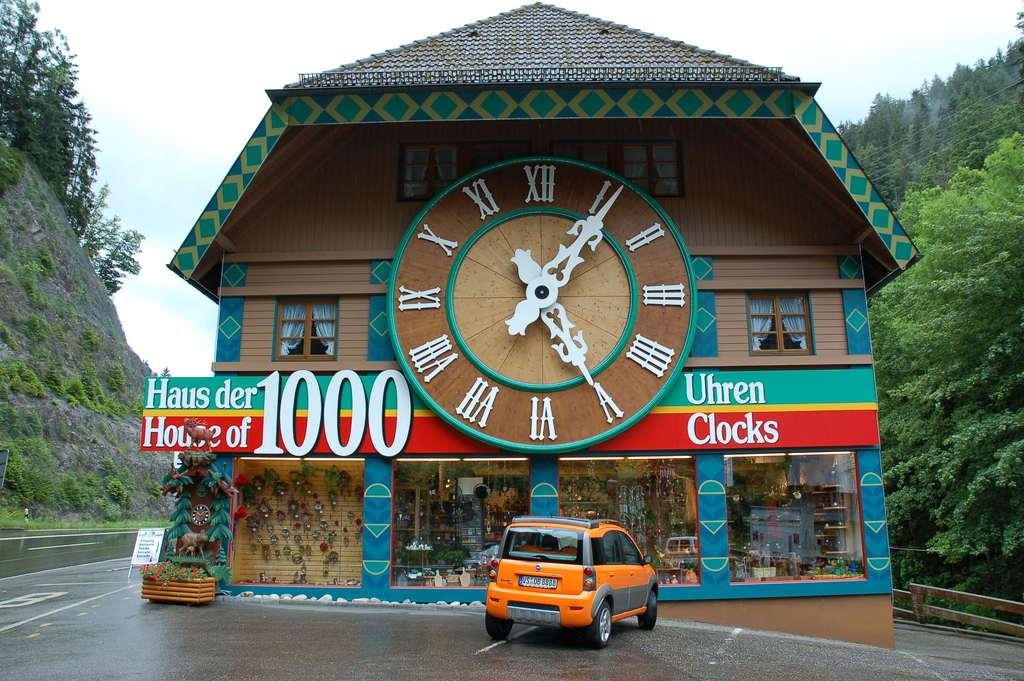<image>
Describe the image concisely. A building with a huge clock on it has the number 1000 on its sign. 